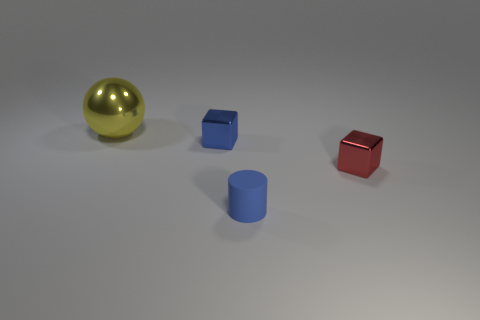Does the large yellow ball have the same material as the blue cube?
Offer a very short reply. Yes. Are there any other tiny objects of the same shape as the yellow thing?
Give a very brief answer. No. Does the shiny cube to the left of the tiny matte object have the same color as the small cylinder?
Offer a terse response. Yes. There is a metal block that is behind the red thing; is its size the same as the shiny thing to the right of the blue shiny block?
Give a very brief answer. Yes. What is the size of the blue object that is the same material as the yellow sphere?
Your answer should be very brief. Small. How many small objects are right of the tiny blue matte object and to the left of the red thing?
Offer a terse response. 0. What number of things are blue metal blocks or metal things that are in front of the yellow metallic thing?
Your response must be concise. 2. What shape is the metal thing that is the same color as the small rubber object?
Your response must be concise. Cube. The tiny metal thing in front of the blue cube is what color?
Keep it short and to the point. Red. What number of things are objects on the right side of the large metal ball or matte cylinders?
Provide a short and direct response. 3. 